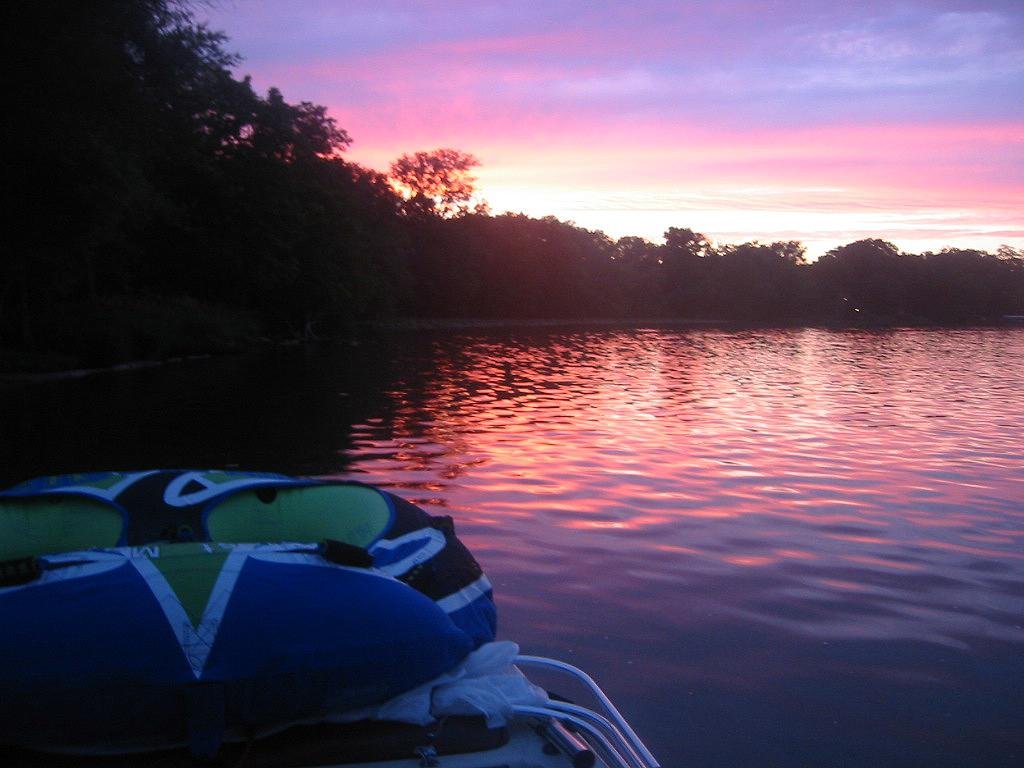What is located on the left side of the image? There is a boat on the left side of the image. What is the primary element in the image? There is water in the image. What type of vegetation can be seen in the middle of the image? There are trees in the middle of the image. What is visible at the top of the image? The sky is visible at the top of the image. What is the rate of the cent in the image? There is no cent or any reference to a rate in the image. What scale is used to measure the size of the trees in the image? There is no scale or measurement of the trees in the image. 